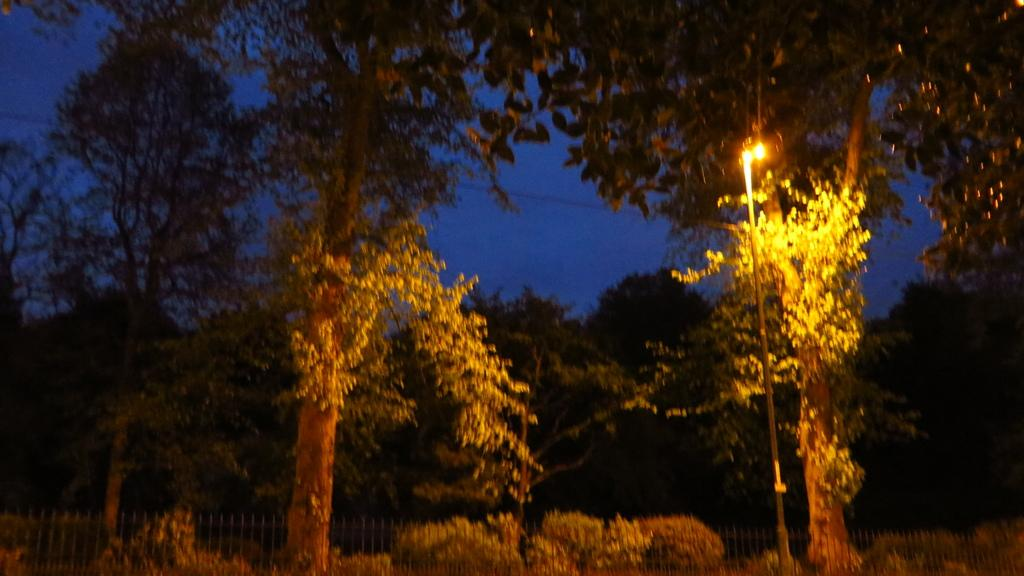What type of vegetation can be seen in the image? There are trees in the image. What structure is present in the image for providing illumination? There is a light pole in the image. What type of barrier is visible in the image? There is fencing in the image. What type of cloth is draped over the trees in the image? There is no cloth draped over the trees in the image; only trees, a light pole, and fencing are present. How many umbrellas can be seen in the image? There are no umbrellas present in the image. 